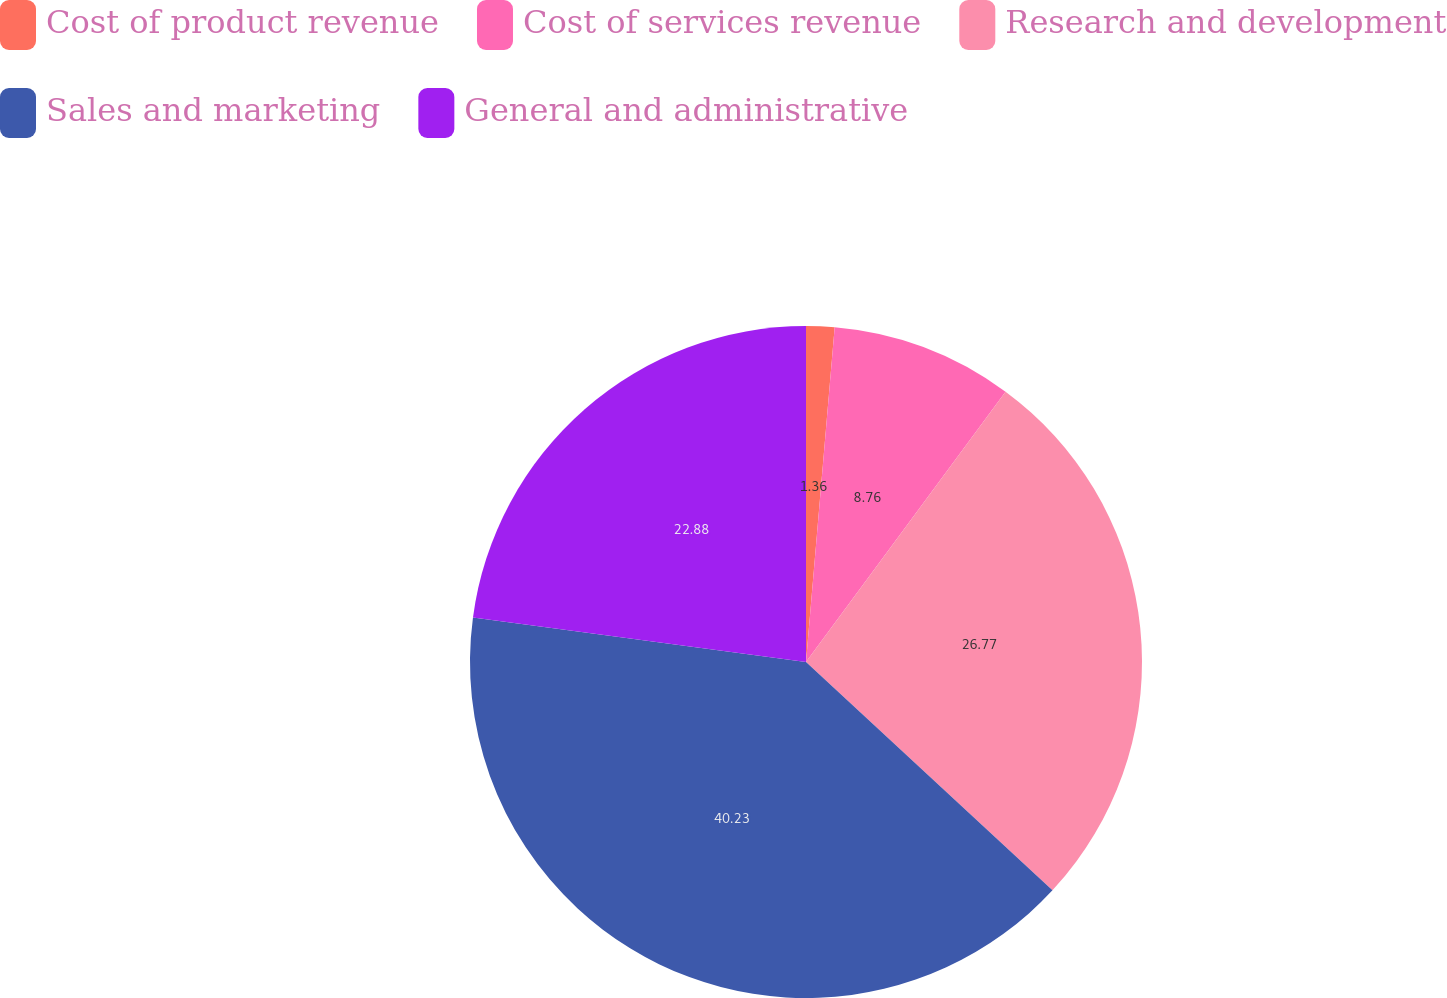Convert chart. <chart><loc_0><loc_0><loc_500><loc_500><pie_chart><fcel>Cost of product revenue<fcel>Cost of services revenue<fcel>Research and development<fcel>Sales and marketing<fcel>General and administrative<nl><fcel>1.36%<fcel>8.76%<fcel>26.77%<fcel>40.22%<fcel>22.88%<nl></chart> 